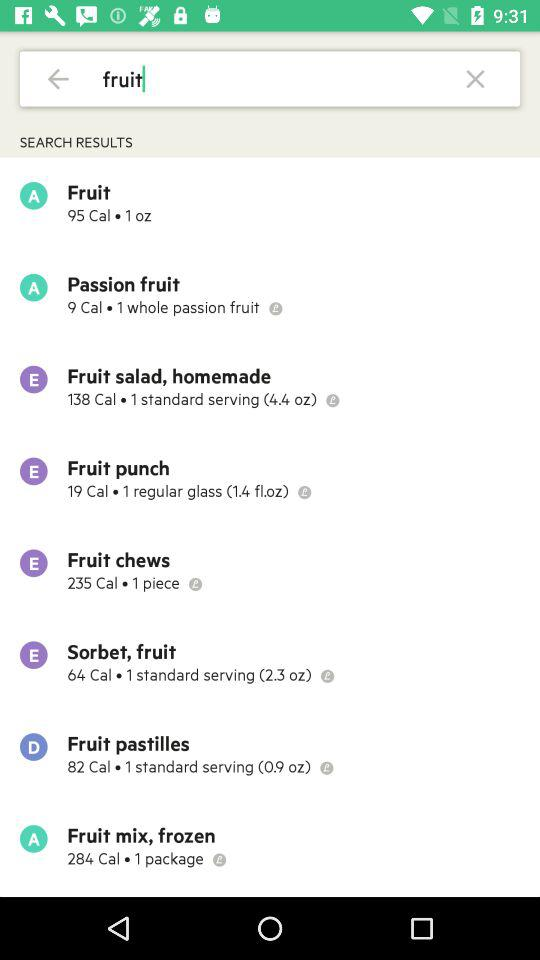How many calories are in "Fruit punch"? There are 19 calories in "Fruit punch". 